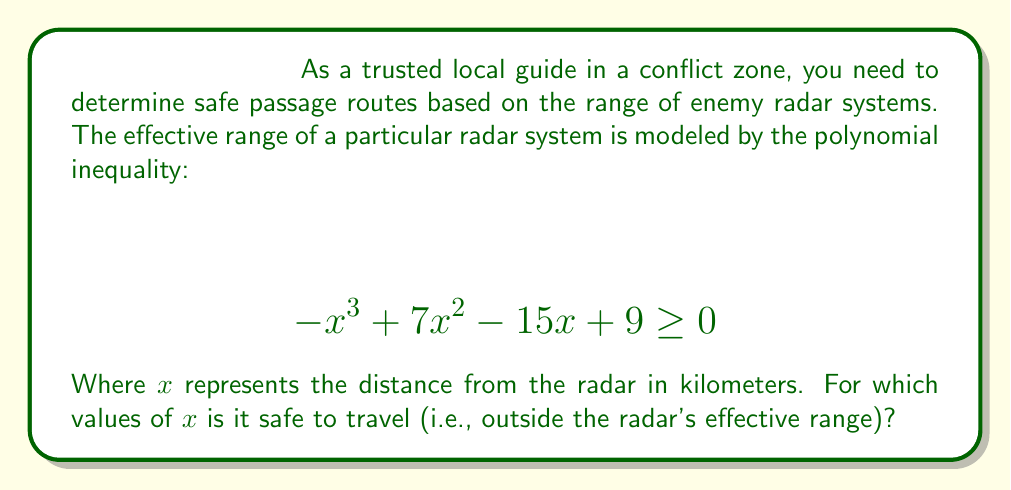Provide a solution to this math problem. To solve this polynomial inequality, we need to follow these steps:

1) First, we need to find the roots of the polynomial $-x^3 + 7x^2 - 15x + 9 = 0$

2) We can factor this polynomial:
   $-x^3 + 7x^2 - 15x + 9 = -(x-1)(x-3)(x-3) = -(x-1)(x-3)^2$

3) The roots are $x = 1$ and $x = 3$ (double root)

4) Now, we need to determine the sign of the polynomial in each interval:
   - For $x < 1$: The polynomial is negative (unsafe)
   - For $1 < x < 3$: The polynomial is positive (safe)
   - For $x > 3$: The polynomial is negative (unsafe)

5) The inequality asks for $-x^3 + 7x^2 - 15x + 9 \geq 0$, which means we're looking for where the polynomial is non-negative.

6) Therefore, the safe zone is $1 \leq x \leq 3$

This means it's safe to travel when you're between 1 and 3 kilometers from the radar system.
Answer: The safe zone is $1 \leq x \leq 3$, or in interval notation, $[1,3]$. 